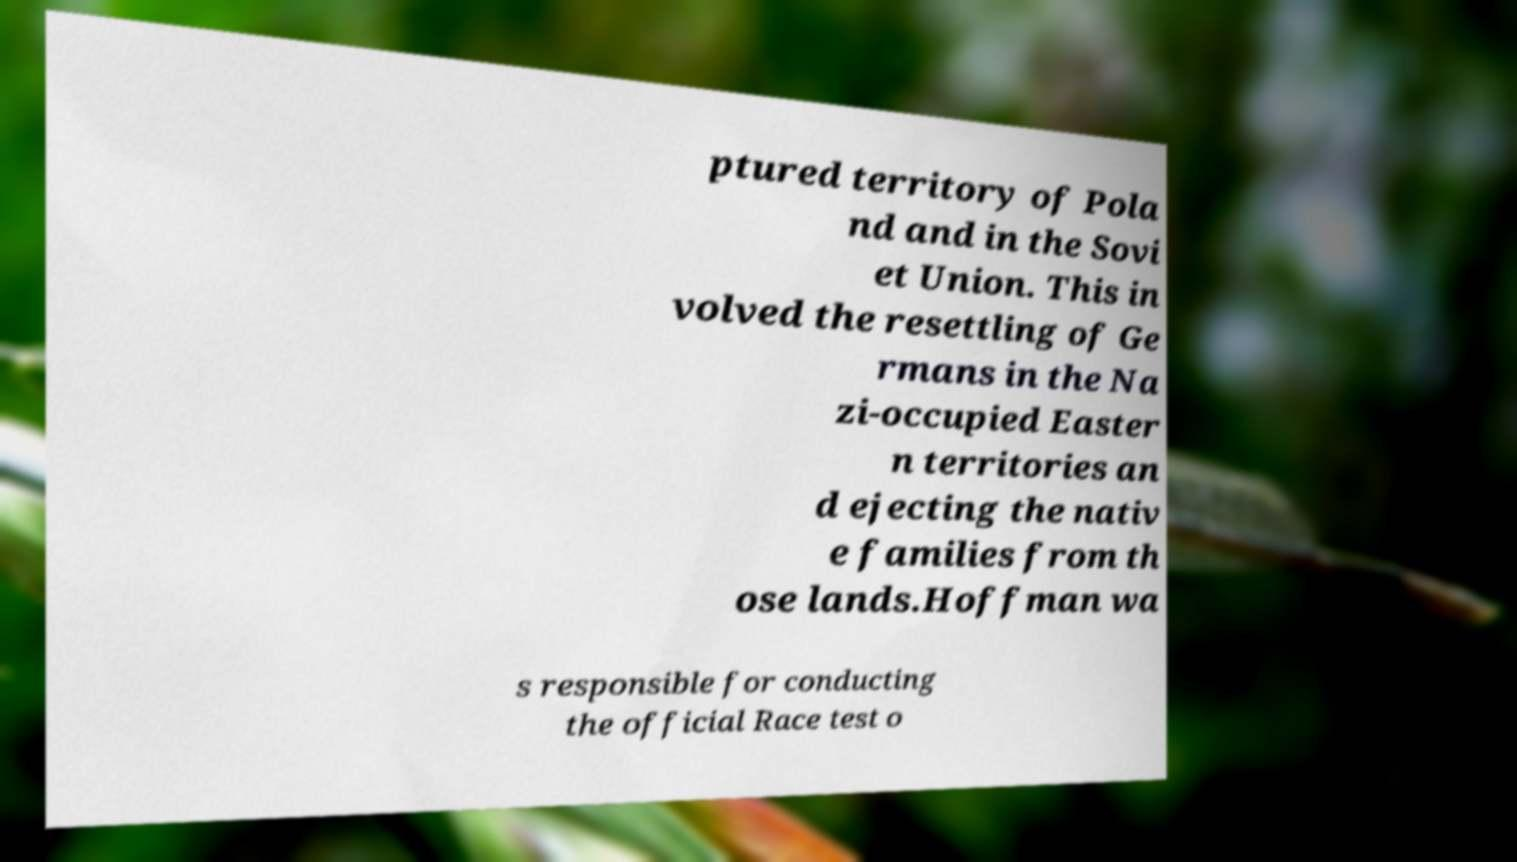Can you accurately transcribe the text from the provided image for me? ptured territory of Pola nd and in the Sovi et Union. This in volved the resettling of Ge rmans in the Na zi-occupied Easter n territories an d ejecting the nativ e families from th ose lands.Hoffman wa s responsible for conducting the official Race test o 